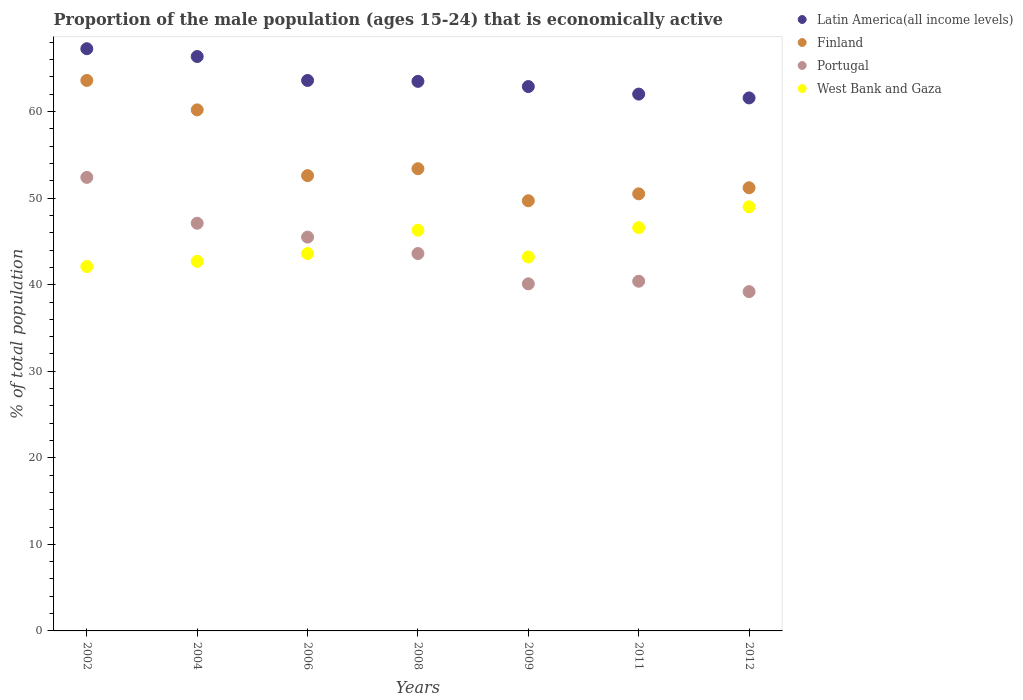What is the proportion of the male population that is economically active in Portugal in 2009?
Ensure brevity in your answer.  40.1. Across all years, what is the minimum proportion of the male population that is economically active in Portugal?
Provide a succinct answer. 39.2. In which year was the proportion of the male population that is economically active in Portugal maximum?
Offer a very short reply. 2002. In which year was the proportion of the male population that is economically active in Portugal minimum?
Keep it short and to the point. 2012. What is the total proportion of the male population that is economically active in West Bank and Gaza in the graph?
Offer a very short reply. 313.5. What is the difference between the proportion of the male population that is economically active in Finland in 2006 and that in 2009?
Your answer should be very brief. 2.9. What is the difference between the proportion of the male population that is economically active in West Bank and Gaza in 2011 and the proportion of the male population that is economically active in Latin America(all income levels) in 2002?
Your response must be concise. -20.66. What is the average proportion of the male population that is economically active in Portugal per year?
Provide a succinct answer. 44.04. In the year 2009, what is the difference between the proportion of the male population that is economically active in Latin America(all income levels) and proportion of the male population that is economically active in West Bank and Gaza?
Give a very brief answer. 19.69. What is the ratio of the proportion of the male population that is economically active in West Bank and Gaza in 2002 to that in 2011?
Keep it short and to the point. 0.9. Is the proportion of the male population that is economically active in West Bank and Gaza in 2002 less than that in 2006?
Provide a short and direct response. Yes. Is the difference between the proportion of the male population that is economically active in Latin America(all income levels) in 2008 and 2011 greater than the difference between the proportion of the male population that is economically active in West Bank and Gaza in 2008 and 2011?
Your response must be concise. Yes. What is the difference between the highest and the second highest proportion of the male population that is economically active in West Bank and Gaza?
Your answer should be compact. 2.4. What is the difference between the highest and the lowest proportion of the male population that is economically active in Finland?
Give a very brief answer. 13.9. In how many years, is the proportion of the male population that is economically active in West Bank and Gaza greater than the average proportion of the male population that is economically active in West Bank and Gaza taken over all years?
Your answer should be very brief. 3. Is the sum of the proportion of the male population that is economically active in Portugal in 2008 and 2009 greater than the maximum proportion of the male population that is economically active in Finland across all years?
Provide a succinct answer. Yes. Is it the case that in every year, the sum of the proportion of the male population that is economically active in Portugal and proportion of the male population that is economically active in West Bank and Gaza  is greater than the sum of proportion of the male population that is economically active in Latin America(all income levels) and proportion of the male population that is economically active in Finland?
Offer a terse response. No. Is the proportion of the male population that is economically active in Latin America(all income levels) strictly less than the proportion of the male population that is economically active in Finland over the years?
Make the answer very short. No. How many years are there in the graph?
Keep it short and to the point. 7. Are the values on the major ticks of Y-axis written in scientific E-notation?
Offer a terse response. No. Does the graph contain any zero values?
Offer a terse response. No. What is the title of the graph?
Your answer should be very brief. Proportion of the male population (ages 15-24) that is economically active. What is the label or title of the X-axis?
Your response must be concise. Years. What is the label or title of the Y-axis?
Give a very brief answer. % of total population. What is the % of total population of Latin America(all income levels) in 2002?
Make the answer very short. 67.26. What is the % of total population in Finland in 2002?
Ensure brevity in your answer.  63.6. What is the % of total population in Portugal in 2002?
Your answer should be compact. 52.4. What is the % of total population in West Bank and Gaza in 2002?
Provide a short and direct response. 42.1. What is the % of total population of Latin America(all income levels) in 2004?
Offer a terse response. 66.36. What is the % of total population in Finland in 2004?
Provide a succinct answer. 60.2. What is the % of total population in Portugal in 2004?
Give a very brief answer. 47.1. What is the % of total population in West Bank and Gaza in 2004?
Your answer should be very brief. 42.7. What is the % of total population of Latin America(all income levels) in 2006?
Give a very brief answer. 63.6. What is the % of total population of Finland in 2006?
Provide a short and direct response. 52.6. What is the % of total population in Portugal in 2006?
Provide a succinct answer. 45.5. What is the % of total population in West Bank and Gaza in 2006?
Your response must be concise. 43.6. What is the % of total population of Latin America(all income levels) in 2008?
Provide a succinct answer. 63.49. What is the % of total population in Finland in 2008?
Provide a short and direct response. 53.4. What is the % of total population in Portugal in 2008?
Offer a terse response. 43.6. What is the % of total population in West Bank and Gaza in 2008?
Your response must be concise. 46.3. What is the % of total population in Latin America(all income levels) in 2009?
Ensure brevity in your answer.  62.89. What is the % of total population in Finland in 2009?
Your answer should be compact. 49.7. What is the % of total population in Portugal in 2009?
Ensure brevity in your answer.  40.1. What is the % of total population of West Bank and Gaza in 2009?
Offer a very short reply. 43.2. What is the % of total population of Latin America(all income levels) in 2011?
Provide a succinct answer. 62.02. What is the % of total population in Finland in 2011?
Make the answer very short. 50.5. What is the % of total population in Portugal in 2011?
Keep it short and to the point. 40.4. What is the % of total population of West Bank and Gaza in 2011?
Offer a very short reply. 46.6. What is the % of total population in Latin America(all income levels) in 2012?
Your response must be concise. 61.58. What is the % of total population in Finland in 2012?
Keep it short and to the point. 51.2. What is the % of total population of Portugal in 2012?
Offer a terse response. 39.2. Across all years, what is the maximum % of total population of Latin America(all income levels)?
Your answer should be compact. 67.26. Across all years, what is the maximum % of total population of Finland?
Offer a very short reply. 63.6. Across all years, what is the maximum % of total population in Portugal?
Keep it short and to the point. 52.4. Across all years, what is the maximum % of total population of West Bank and Gaza?
Give a very brief answer. 49. Across all years, what is the minimum % of total population of Latin America(all income levels)?
Make the answer very short. 61.58. Across all years, what is the minimum % of total population in Finland?
Your answer should be very brief. 49.7. Across all years, what is the minimum % of total population in Portugal?
Your answer should be very brief. 39.2. Across all years, what is the minimum % of total population in West Bank and Gaza?
Provide a short and direct response. 42.1. What is the total % of total population in Latin America(all income levels) in the graph?
Offer a terse response. 447.21. What is the total % of total population in Finland in the graph?
Your response must be concise. 381.2. What is the total % of total population in Portugal in the graph?
Ensure brevity in your answer.  308.3. What is the total % of total population of West Bank and Gaza in the graph?
Give a very brief answer. 313.5. What is the difference between the % of total population of Latin America(all income levels) in 2002 and that in 2004?
Give a very brief answer. 0.9. What is the difference between the % of total population in Finland in 2002 and that in 2004?
Give a very brief answer. 3.4. What is the difference between the % of total population of Portugal in 2002 and that in 2004?
Your response must be concise. 5.3. What is the difference between the % of total population of West Bank and Gaza in 2002 and that in 2004?
Offer a terse response. -0.6. What is the difference between the % of total population in Latin America(all income levels) in 2002 and that in 2006?
Your response must be concise. 3.67. What is the difference between the % of total population of Finland in 2002 and that in 2006?
Offer a very short reply. 11. What is the difference between the % of total population of West Bank and Gaza in 2002 and that in 2006?
Offer a very short reply. -1.5. What is the difference between the % of total population of Latin America(all income levels) in 2002 and that in 2008?
Offer a very short reply. 3.77. What is the difference between the % of total population of Finland in 2002 and that in 2008?
Give a very brief answer. 10.2. What is the difference between the % of total population in Portugal in 2002 and that in 2008?
Offer a very short reply. 8.8. What is the difference between the % of total population of Latin America(all income levels) in 2002 and that in 2009?
Keep it short and to the point. 4.37. What is the difference between the % of total population of Finland in 2002 and that in 2009?
Make the answer very short. 13.9. What is the difference between the % of total population of West Bank and Gaza in 2002 and that in 2009?
Offer a very short reply. -1.1. What is the difference between the % of total population in Latin America(all income levels) in 2002 and that in 2011?
Your answer should be very brief. 5.24. What is the difference between the % of total population in Finland in 2002 and that in 2011?
Your answer should be compact. 13.1. What is the difference between the % of total population in West Bank and Gaza in 2002 and that in 2011?
Offer a terse response. -4.5. What is the difference between the % of total population of Latin America(all income levels) in 2002 and that in 2012?
Ensure brevity in your answer.  5.69. What is the difference between the % of total population in West Bank and Gaza in 2002 and that in 2012?
Provide a short and direct response. -6.9. What is the difference between the % of total population of Latin America(all income levels) in 2004 and that in 2006?
Provide a short and direct response. 2.77. What is the difference between the % of total population in Portugal in 2004 and that in 2006?
Give a very brief answer. 1.6. What is the difference between the % of total population of West Bank and Gaza in 2004 and that in 2006?
Keep it short and to the point. -0.9. What is the difference between the % of total population in Latin America(all income levels) in 2004 and that in 2008?
Give a very brief answer. 2.87. What is the difference between the % of total population of Finland in 2004 and that in 2008?
Ensure brevity in your answer.  6.8. What is the difference between the % of total population of Latin America(all income levels) in 2004 and that in 2009?
Offer a terse response. 3.47. What is the difference between the % of total population of Portugal in 2004 and that in 2009?
Offer a terse response. 7. What is the difference between the % of total population in Latin America(all income levels) in 2004 and that in 2011?
Your answer should be compact. 4.34. What is the difference between the % of total population of Finland in 2004 and that in 2011?
Provide a succinct answer. 9.7. What is the difference between the % of total population in Portugal in 2004 and that in 2011?
Provide a succinct answer. 6.7. What is the difference between the % of total population of Latin America(all income levels) in 2004 and that in 2012?
Your answer should be very brief. 4.78. What is the difference between the % of total population in West Bank and Gaza in 2004 and that in 2012?
Give a very brief answer. -6.3. What is the difference between the % of total population in Latin America(all income levels) in 2006 and that in 2008?
Provide a short and direct response. 0.1. What is the difference between the % of total population in Finland in 2006 and that in 2008?
Provide a short and direct response. -0.8. What is the difference between the % of total population in Portugal in 2006 and that in 2008?
Offer a very short reply. 1.9. What is the difference between the % of total population of Latin America(all income levels) in 2006 and that in 2009?
Give a very brief answer. 0.7. What is the difference between the % of total population in Latin America(all income levels) in 2006 and that in 2011?
Offer a very short reply. 1.58. What is the difference between the % of total population in Latin America(all income levels) in 2006 and that in 2012?
Make the answer very short. 2.02. What is the difference between the % of total population in Finland in 2006 and that in 2012?
Your response must be concise. 1.4. What is the difference between the % of total population in Portugal in 2006 and that in 2012?
Make the answer very short. 6.3. What is the difference between the % of total population in West Bank and Gaza in 2006 and that in 2012?
Keep it short and to the point. -5.4. What is the difference between the % of total population in Latin America(all income levels) in 2008 and that in 2009?
Ensure brevity in your answer.  0.6. What is the difference between the % of total population in Portugal in 2008 and that in 2009?
Ensure brevity in your answer.  3.5. What is the difference between the % of total population in West Bank and Gaza in 2008 and that in 2009?
Ensure brevity in your answer.  3.1. What is the difference between the % of total population of Latin America(all income levels) in 2008 and that in 2011?
Give a very brief answer. 1.47. What is the difference between the % of total population of Finland in 2008 and that in 2011?
Provide a short and direct response. 2.9. What is the difference between the % of total population in Portugal in 2008 and that in 2011?
Your answer should be very brief. 3.2. What is the difference between the % of total population of Latin America(all income levels) in 2008 and that in 2012?
Offer a very short reply. 1.91. What is the difference between the % of total population in Portugal in 2008 and that in 2012?
Give a very brief answer. 4.4. What is the difference between the % of total population of Latin America(all income levels) in 2009 and that in 2011?
Give a very brief answer. 0.87. What is the difference between the % of total population of Portugal in 2009 and that in 2011?
Your answer should be compact. -0.3. What is the difference between the % of total population in Latin America(all income levels) in 2009 and that in 2012?
Provide a short and direct response. 1.31. What is the difference between the % of total population in Finland in 2009 and that in 2012?
Provide a short and direct response. -1.5. What is the difference between the % of total population in Portugal in 2009 and that in 2012?
Your answer should be compact. 0.9. What is the difference between the % of total population of Latin America(all income levels) in 2011 and that in 2012?
Ensure brevity in your answer.  0.44. What is the difference between the % of total population in Finland in 2011 and that in 2012?
Give a very brief answer. -0.7. What is the difference between the % of total population of Portugal in 2011 and that in 2012?
Provide a succinct answer. 1.2. What is the difference between the % of total population in Latin America(all income levels) in 2002 and the % of total population in Finland in 2004?
Your answer should be compact. 7.06. What is the difference between the % of total population of Latin America(all income levels) in 2002 and the % of total population of Portugal in 2004?
Give a very brief answer. 20.16. What is the difference between the % of total population in Latin America(all income levels) in 2002 and the % of total population in West Bank and Gaza in 2004?
Provide a succinct answer. 24.56. What is the difference between the % of total population of Finland in 2002 and the % of total population of Portugal in 2004?
Offer a terse response. 16.5. What is the difference between the % of total population of Finland in 2002 and the % of total population of West Bank and Gaza in 2004?
Give a very brief answer. 20.9. What is the difference between the % of total population in Portugal in 2002 and the % of total population in West Bank and Gaza in 2004?
Provide a short and direct response. 9.7. What is the difference between the % of total population of Latin America(all income levels) in 2002 and the % of total population of Finland in 2006?
Offer a very short reply. 14.66. What is the difference between the % of total population of Latin America(all income levels) in 2002 and the % of total population of Portugal in 2006?
Your answer should be very brief. 21.76. What is the difference between the % of total population of Latin America(all income levels) in 2002 and the % of total population of West Bank and Gaza in 2006?
Keep it short and to the point. 23.66. What is the difference between the % of total population in Finland in 2002 and the % of total population in West Bank and Gaza in 2006?
Give a very brief answer. 20. What is the difference between the % of total population of Latin America(all income levels) in 2002 and the % of total population of Finland in 2008?
Your answer should be very brief. 13.86. What is the difference between the % of total population in Latin America(all income levels) in 2002 and the % of total population in Portugal in 2008?
Ensure brevity in your answer.  23.66. What is the difference between the % of total population in Latin America(all income levels) in 2002 and the % of total population in West Bank and Gaza in 2008?
Provide a short and direct response. 20.96. What is the difference between the % of total population of Finland in 2002 and the % of total population of Portugal in 2008?
Provide a short and direct response. 20. What is the difference between the % of total population in Latin America(all income levels) in 2002 and the % of total population in Finland in 2009?
Your answer should be compact. 17.56. What is the difference between the % of total population of Latin America(all income levels) in 2002 and the % of total population of Portugal in 2009?
Your response must be concise. 27.16. What is the difference between the % of total population in Latin America(all income levels) in 2002 and the % of total population in West Bank and Gaza in 2009?
Keep it short and to the point. 24.06. What is the difference between the % of total population in Finland in 2002 and the % of total population in West Bank and Gaza in 2009?
Give a very brief answer. 20.4. What is the difference between the % of total population in Portugal in 2002 and the % of total population in West Bank and Gaza in 2009?
Keep it short and to the point. 9.2. What is the difference between the % of total population of Latin America(all income levels) in 2002 and the % of total population of Finland in 2011?
Keep it short and to the point. 16.76. What is the difference between the % of total population of Latin America(all income levels) in 2002 and the % of total population of Portugal in 2011?
Your response must be concise. 26.86. What is the difference between the % of total population of Latin America(all income levels) in 2002 and the % of total population of West Bank and Gaza in 2011?
Your answer should be very brief. 20.66. What is the difference between the % of total population of Finland in 2002 and the % of total population of Portugal in 2011?
Give a very brief answer. 23.2. What is the difference between the % of total population in Finland in 2002 and the % of total population in West Bank and Gaza in 2011?
Keep it short and to the point. 17. What is the difference between the % of total population of Portugal in 2002 and the % of total population of West Bank and Gaza in 2011?
Offer a terse response. 5.8. What is the difference between the % of total population of Latin America(all income levels) in 2002 and the % of total population of Finland in 2012?
Make the answer very short. 16.06. What is the difference between the % of total population in Latin America(all income levels) in 2002 and the % of total population in Portugal in 2012?
Give a very brief answer. 28.06. What is the difference between the % of total population of Latin America(all income levels) in 2002 and the % of total population of West Bank and Gaza in 2012?
Your answer should be compact. 18.26. What is the difference between the % of total population in Finland in 2002 and the % of total population in Portugal in 2012?
Give a very brief answer. 24.4. What is the difference between the % of total population in Finland in 2002 and the % of total population in West Bank and Gaza in 2012?
Keep it short and to the point. 14.6. What is the difference between the % of total population in Latin America(all income levels) in 2004 and the % of total population in Finland in 2006?
Offer a very short reply. 13.76. What is the difference between the % of total population in Latin America(all income levels) in 2004 and the % of total population in Portugal in 2006?
Offer a very short reply. 20.86. What is the difference between the % of total population of Latin America(all income levels) in 2004 and the % of total population of West Bank and Gaza in 2006?
Provide a succinct answer. 22.76. What is the difference between the % of total population in Finland in 2004 and the % of total population in Portugal in 2006?
Keep it short and to the point. 14.7. What is the difference between the % of total population of Latin America(all income levels) in 2004 and the % of total population of Finland in 2008?
Your answer should be very brief. 12.96. What is the difference between the % of total population of Latin America(all income levels) in 2004 and the % of total population of Portugal in 2008?
Your answer should be very brief. 22.76. What is the difference between the % of total population in Latin America(all income levels) in 2004 and the % of total population in West Bank and Gaza in 2008?
Provide a succinct answer. 20.06. What is the difference between the % of total population of Finland in 2004 and the % of total population of West Bank and Gaza in 2008?
Your answer should be compact. 13.9. What is the difference between the % of total population in Latin America(all income levels) in 2004 and the % of total population in Finland in 2009?
Make the answer very short. 16.66. What is the difference between the % of total population of Latin America(all income levels) in 2004 and the % of total population of Portugal in 2009?
Provide a succinct answer. 26.26. What is the difference between the % of total population in Latin America(all income levels) in 2004 and the % of total population in West Bank and Gaza in 2009?
Provide a succinct answer. 23.16. What is the difference between the % of total population of Finland in 2004 and the % of total population of Portugal in 2009?
Make the answer very short. 20.1. What is the difference between the % of total population of Finland in 2004 and the % of total population of West Bank and Gaza in 2009?
Make the answer very short. 17. What is the difference between the % of total population in Portugal in 2004 and the % of total population in West Bank and Gaza in 2009?
Provide a succinct answer. 3.9. What is the difference between the % of total population of Latin America(all income levels) in 2004 and the % of total population of Finland in 2011?
Keep it short and to the point. 15.86. What is the difference between the % of total population of Latin America(all income levels) in 2004 and the % of total population of Portugal in 2011?
Provide a short and direct response. 25.96. What is the difference between the % of total population of Latin America(all income levels) in 2004 and the % of total population of West Bank and Gaza in 2011?
Keep it short and to the point. 19.76. What is the difference between the % of total population of Finland in 2004 and the % of total population of Portugal in 2011?
Provide a short and direct response. 19.8. What is the difference between the % of total population in Finland in 2004 and the % of total population in West Bank and Gaza in 2011?
Your answer should be very brief. 13.6. What is the difference between the % of total population in Portugal in 2004 and the % of total population in West Bank and Gaza in 2011?
Offer a very short reply. 0.5. What is the difference between the % of total population in Latin America(all income levels) in 2004 and the % of total population in Finland in 2012?
Keep it short and to the point. 15.16. What is the difference between the % of total population in Latin America(all income levels) in 2004 and the % of total population in Portugal in 2012?
Make the answer very short. 27.16. What is the difference between the % of total population of Latin America(all income levels) in 2004 and the % of total population of West Bank and Gaza in 2012?
Make the answer very short. 17.36. What is the difference between the % of total population of Finland in 2004 and the % of total population of Portugal in 2012?
Offer a very short reply. 21. What is the difference between the % of total population in Finland in 2004 and the % of total population in West Bank and Gaza in 2012?
Ensure brevity in your answer.  11.2. What is the difference between the % of total population of Latin America(all income levels) in 2006 and the % of total population of Finland in 2008?
Ensure brevity in your answer.  10.2. What is the difference between the % of total population of Latin America(all income levels) in 2006 and the % of total population of Portugal in 2008?
Provide a succinct answer. 20. What is the difference between the % of total population of Latin America(all income levels) in 2006 and the % of total population of West Bank and Gaza in 2008?
Give a very brief answer. 17.3. What is the difference between the % of total population of Finland in 2006 and the % of total population of West Bank and Gaza in 2008?
Give a very brief answer. 6.3. What is the difference between the % of total population of Latin America(all income levels) in 2006 and the % of total population of Finland in 2009?
Provide a succinct answer. 13.9. What is the difference between the % of total population in Latin America(all income levels) in 2006 and the % of total population in Portugal in 2009?
Make the answer very short. 23.5. What is the difference between the % of total population of Latin America(all income levels) in 2006 and the % of total population of West Bank and Gaza in 2009?
Offer a very short reply. 20.4. What is the difference between the % of total population in Finland in 2006 and the % of total population in Portugal in 2009?
Offer a very short reply. 12.5. What is the difference between the % of total population in Portugal in 2006 and the % of total population in West Bank and Gaza in 2009?
Your answer should be compact. 2.3. What is the difference between the % of total population in Latin America(all income levels) in 2006 and the % of total population in Finland in 2011?
Give a very brief answer. 13.1. What is the difference between the % of total population in Latin America(all income levels) in 2006 and the % of total population in Portugal in 2011?
Offer a terse response. 23.2. What is the difference between the % of total population of Latin America(all income levels) in 2006 and the % of total population of West Bank and Gaza in 2011?
Keep it short and to the point. 17. What is the difference between the % of total population in Finland in 2006 and the % of total population in West Bank and Gaza in 2011?
Ensure brevity in your answer.  6. What is the difference between the % of total population of Portugal in 2006 and the % of total population of West Bank and Gaza in 2011?
Your answer should be very brief. -1.1. What is the difference between the % of total population of Latin America(all income levels) in 2006 and the % of total population of Finland in 2012?
Offer a terse response. 12.4. What is the difference between the % of total population of Latin America(all income levels) in 2006 and the % of total population of Portugal in 2012?
Provide a succinct answer. 24.4. What is the difference between the % of total population in Latin America(all income levels) in 2006 and the % of total population in West Bank and Gaza in 2012?
Ensure brevity in your answer.  14.6. What is the difference between the % of total population in Finland in 2006 and the % of total population in Portugal in 2012?
Give a very brief answer. 13.4. What is the difference between the % of total population of Finland in 2006 and the % of total population of West Bank and Gaza in 2012?
Keep it short and to the point. 3.6. What is the difference between the % of total population of Latin America(all income levels) in 2008 and the % of total population of Finland in 2009?
Make the answer very short. 13.79. What is the difference between the % of total population in Latin America(all income levels) in 2008 and the % of total population in Portugal in 2009?
Make the answer very short. 23.39. What is the difference between the % of total population in Latin America(all income levels) in 2008 and the % of total population in West Bank and Gaza in 2009?
Keep it short and to the point. 20.29. What is the difference between the % of total population in Finland in 2008 and the % of total population in Portugal in 2009?
Make the answer very short. 13.3. What is the difference between the % of total population in Portugal in 2008 and the % of total population in West Bank and Gaza in 2009?
Give a very brief answer. 0.4. What is the difference between the % of total population of Latin America(all income levels) in 2008 and the % of total population of Finland in 2011?
Offer a very short reply. 12.99. What is the difference between the % of total population in Latin America(all income levels) in 2008 and the % of total population in Portugal in 2011?
Ensure brevity in your answer.  23.09. What is the difference between the % of total population in Latin America(all income levels) in 2008 and the % of total population in West Bank and Gaza in 2011?
Your answer should be very brief. 16.89. What is the difference between the % of total population of Finland in 2008 and the % of total population of Portugal in 2011?
Give a very brief answer. 13. What is the difference between the % of total population in Portugal in 2008 and the % of total population in West Bank and Gaza in 2011?
Your answer should be compact. -3. What is the difference between the % of total population in Latin America(all income levels) in 2008 and the % of total population in Finland in 2012?
Offer a very short reply. 12.29. What is the difference between the % of total population of Latin America(all income levels) in 2008 and the % of total population of Portugal in 2012?
Your answer should be very brief. 24.29. What is the difference between the % of total population in Latin America(all income levels) in 2008 and the % of total population in West Bank and Gaza in 2012?
Give a very brief answer. 14.49. What is the difference between the % of total population of Finland in 2008 and the % of total population of West Bank and Gaza in 2012?
Your response must be concise. 4.4. What is the difference between the % of total population in Portugal in 2008 and the % of total population in West Bank and Gaza in 2012?
Your answer should be very brief. -5.4. What is the difference between the % of total population of Latin America(all income levels) in 2009 and the % of total population of Finland in 2011?
Your response must be concise. 12.39. What is the difference between the % of total population in Latin America(all income levels) in 2009 and the % of total population in Portugal in 2011?
Keep it short and to the point. 22.49. What is the difference between the % of total population of Latin America(all income levels) in 2009 and the % of total population of West Bank and Gaza in 2011?
Offer a very short reply. 16.29. What is the difference between the % of total population in Finland in 2009 and the % of total population in West Bank and Gaza in 2011?
Give a very brief answer. 3.1. What is the difference between the % of total population of Latin America(all income levels) in 2009 and the % of total population of Finland in 2012?
Keep it short and to the point. 11.69. What is the difference between the % of total population of Latin America(all income levels) in 2009 and the % of total population of Portugal in 2012?
Your answer should be compact. 23.69. What is the difference between the % of total population in Latin America(all income levels) in 2009 and the % of total population in West Bank and Gaza in 2012?
Provide a succinct answer. 13.89. What is the difference between the % of total population in Finland in 2009 and the % of total population in Portugal in 2012?
Keep it short and to the point. 10.5. What is the difference between the % of total population of Finland in 2009 and the % of total population of West Bank and Gaza in 2012?
Make the answer very short. 0.7. What is the difference between the % of total population of Portugal in 2009 and the % of total population of West Bank and Gaza in 2012?
Offer a very short reply. -8.9. What is the difference between the % of total population in Latin America(all income levels) in 2011 and the % of total population in Finland in 2012?
Your answer should be very brief. 10.82. What is the difference between the % of total population in Latin America(all income levels) in 2011 and the % of total population in Portugal in 2012?
Ensure brevity in your answer.  22.82. What is the difference between the % of total population of Latin America(all income levels) in 2011 and the % of total population of West Bank and Gaza in 2012?
Ensure brevity in your answer.  13.02. What is the difference between the % of total population of Finland in 2011 and the % of total population of West Bank and Gaza in 2012?
Offer a very short reply. 1.5. What is the difference between the % of total population in Portugal in 2011 and the % of total population in West Bank and Gaza in 2012?
Make the answer very short. -8.6. What is the average % of total population of Latin America(all income levels) per year?
Provide a short and direct response. 63.89. What is the average % of total population of Finland per year?
Offer a very short reply. 54.46. What is the average % of total population of Portugal per year?
Provide a succinct answer. 44.04. What is the average % of total population of West Bank and Gaza per year?
Provide a short and direct response. 44.79. In the year 2002, what is the difference between the % of total population of Latin America(all income levels) and % of total population of Finland?
Offer a very short reply. 3.66. In the year 2002, what is the difference between the % of total population in Latin America(all income levels) and % of total population in Portugal?
Offer a terse response. 14.86. In the year 2002, what is the difference between the % of total population of Latin America(all income levels) and % of total population of West Bank and Gaza?
Give a very brief answer. 25.16. In the year 2004, what is the difference between the % of total population in Latin America(all income levels) and % of total population in Finland?
Offer a very short reply. 6.16. In the year 2004, what is the difference between the % of total population in Latin America(all income levels) and % of total population in Portugal?
Keep it short and to the point. 19.26. In the year 2004, what is the difference between the % of total population in Latin America(all income levels) and % of total population in West Bank and Gaza?
Your answer should be compact. 23.66. In the year 2004, what is the difference between the % of total population of Finland and % of total population of Portugal?
Make the answer very short. 13.1. In the year 2006, what is the difference between the % of total population of Latin America(all income levels) and % of total population of Finland?
Your response must be concise. 11. In the year 2006, what is the difference between the % of total population in Latin America(all income levels) and % of total population in Portugal?
Provide a short and direct response. 18.1. In the year 2006, what is the difference between the % of total population of Latin America(all income levels) and % of total population of West Bank and Gaza?
Offer a very short reply. 20. In the year 2006, what is the difference between the % of total population of Finland and % of total population of Portugal?
Your response must be concise. 7.1. In the year 2006, what is the difference between the % of total population in Finland and % of total population in West Bank and Gaza?
Give a very brief answer. 9. In the year 2006, what is the difference between the % of total population in Portugal and % of total population in West Bank and Gaza?
Ensure brevity in your answer.  1.9. In the year 2008, what is the difference between the % of total population of Latin America(all income levels) and % of total population of Finland?
Ensure brevity in your answer.  10.09. In the year 2008, what is the difference between the % of total population of Latin America(all income levels) and % of total population of Portugal?
Ensure brevity in your answer.  19.89. In the year 2008, what is the difference between the % of total population of Latin America(all income levels) and % of total population of West Bank and Gaza?
Give a very brief answer. 17.19. In the year 2009, what is the difference between the % of total population in Latin America(all income levels) and % of total population in Finland?
Your response must be concise. 13.19. In the year 2009, what is the difference between the % of total population in Latin America(all income levels) and % of total population in Portugal?
Your answer should be very brief. 22.79. In the year 2009, what is the difference between the % of total population of Latin America(all income levels) and % of total population of West Bank and Gaza?
Your response must be concise. 19.69. In the year 2009, what is the difference between the % of total population in Finland and % of total population in Portugal?
Your answer should be very brief. 9.6. In the year 2009, what is the difference between the % of total population of Finland and % of total population of West Bank and Gaza?
Ensure brevity in your answer.  6.5. In the year 2011, what is the difference between the % of total population of Latin America(all income levels) and % of total population of Finland?
Ensure brevity in your answer.  11.52. In the year 2011, what is the difference between the % of total population of Latin America(all income levels) and % of total population of Portugal?
Ensure brevity in your answer.  21.62. In the year 2011, what is the difference between the % of total population in Latin America(all income levels) and % of total population in West Bank and Gaza?
Provide a succinct answer. 15.42. In the year 2011, what is the difference between the % of total population of Finland and % of total population of Portugal?
Provide a succinct answer. 10.1. In the year 2011, what is the difference between the % of total population of Finland and % of total population of West Bank and Gaza?
Offer a very short reply. 3.9. In the year 2011, what is the difference between the % of total population in Portugal and % of total population in West Bank and Gaza?
Give a very brief answer. -6.2. In the year 2012, what is the difference between the % of total population in Latin America(all income levels) and % of total population in Finland?
Ensure brevity in your answer.  10.38. In the year 2012, what is the difference between the % of total population in Latin America(all income levels) and % of total population in Portugal?
Offer a very short reply. 22.38. In the year 2012, what is the difference between the % of total population of Latin America(all income levels) and % of total population of West Bank and Gaza?
Provide a short and direct response. 12.58. In the year 2012, what is the difference between the % of total population of Portugal and % of total population of West Bank and Gaza?
Offer a terse response. -9.8. What is the ratio of the % of total population in Latin America(all income levels) in 2002 to that in 2004?
Give a very brief answer. 1.01. What is the ratio of the % of total population of Finland in 2002 to that in 2004?
Give a very brief answer. 1.06. What is the ratio of the % of total population in Portugal in 2002 to that in 2004?
Your response must be concise. 1.11. What is the ratio of the % of total population in West Bank and Gaza in 2002 to that in 2004?
Your answer should be compact. 0.99. What is the ratio of the % of total population of Latin America(all income levels) in 2002 to that in 2006?
Provide a short and direct response. 1.06. What is the ratio of the % of total population in Finland in 2002 to that in 2006?
Provide a succinct answer. 1.21. What is the ratio of the % of total population of Portugal in 2002 to that in 2006?
Offer a terse response. 1.15. What is the ratio of the % of total population in West Bank and Gaza in 2002 to that in 2006?
Give a very brief answer. 0.97. What is the ratio of the % of total population of Latin America(all income levels) in 2002 to that in 2008?
Ensure brevity in your answer.  1.06. What is the ratio of the % of total population in Finland in 2002 to that in 2008?
Give a very brief answer. 1.19. What is the ratio of the % of total population in Portugal in 2002 to that in 2008?
Your answer should be very brief. 1.2. What is the ratio of the % of total population in West Bank and Gaza in 2002 to that in 2008?
Provide a short and direct response. 0.91. What is the ratio of the % of total population in Latin America(all income levels) in 2002 to that in 2009?
Provide a succinct answer. 1.07. What is the ratio of the % of total population of Finland in 2002 to that in 2009?
Your answer should be compact. 1.28. What is the ratio of the % of total population in Portugal in 2002 to that in 2009?
Ensure brevity in your answer.  1.31. What is the ratio of the % of total population in West Bank and Gaza in 2002 to that in 2009?
Give a very brief answer. 0.97. What is the ratio of the % of total population in Latin America(all income levels) in 2002 to that in 2011?
Make the answer very short. 1.08. What is the ratio of the % of total population in Finland in 2002 to that in 2011?
Your answer should be compact. 1.26. What is the ratio of the % of total population in Portugal in 2002 to that in 2011?
Keep it short and to the point. 1.3. What is the ratio of the % of total population of West Bank and Gaza in 2002 to that in 2011?
Give a very brief answer. 0.9. What is the ratio of the % of total population of Latin America(all income levels) in 2002 to that in 2012?
Offer a terse response. 1.09. What is the ratio of the % of total population in Finland in 2002 to that in 2012?
Provide a succinct answer. 1.24. What is the ratio of the % of total population of Portugal in 2002 to that in 2012?
Offer a very short reply. 1.34. What is the ratio of the % of total population in West Bank and Gaza in 2002 to that in 2012?
Your answer should be compact. 0.86. What is the ratio of the % of total population of Latin America(all income levels) in 2004 to that in 2006?
Give a very brief answer. 1.04. What is the ratio of the % of total population in Finland in 2004 to that in 2006?
Give a very brief answer. 1.14. What is the ratio of the % of total population in Portugal in 2004 to that in 2006?
Your response must be concise. 1.04. What is the ratio of the % of total population in West Bank and Gaza in 2004 to that in 2006?
Make the answer very short. 0.98. What is the ratio of the % of total population of Latin America(all income levels) in 2004 to that in 2008?
Provide a succinct answer. 1.05. What is the ratio of the % of total population in Finland in 2004 to that in 2008?
Give a very brief answer. 1.13. What is the ratio of the % of total population of Portugal in 2004 to that in 2008?
Keep it short and to the point. 1.08. What is the ratio of the % of total population in West Bank and Gaza in 2004 to that in 2008?
Your response must be concise. 0.92. What is the ratio of the % of total population of Latin America(all income levels) in 2004 to that in 2009?
Offer a terse response. 1.06. What is the ratio of the % of total population of Finland in 2004 to that in 2009?
Make the answer very short. 1.21. What is the ratio of the % of total population of Portugal in 2004 to that in 2009?
Provide a succinct answer. 1.17. What is the ratio of the % of total population of West Bank and Gaza in 2004 to that in 2009?
Ensure brevity in your answer.  0.99. What is the ratio of the % of total population of Latin America(all income levels) in 2004 to that in 2011?
Your answer should be very brief. 1.07. What is the ratio of the % of total population of Finland in 2004 to that in 2011?
Your answer should be very brief. 1.19. What is the ratio of the % of total population in Portugal in 2004 to that in 2011?
Offer a terse response. 1.17. What is the ratio of the % of total population in West Bank and Gaza in 2004 to that in 2011?
Your answer should be very brief. 0.92. What is the ratio of the % of total population of Latin America(all income levels) in 2004 to that in 2012?
Your answer should be very brief. 1.08. What is the ratio of the % of total population in Finland in 2004 to that in 2012?
Your answer should be compact. 1.18. What is the ratio of the % of total population of Portugal in 2004 to that in 2012?
Provide a succinct answer. 1.2. What is the ratio of the % of total population in West Bank and Gaza in 2004 to that in 2012?
Your answer should be very brief. 0.87. What is the ratio of the % of total population in Latin America(all income levels) in 2006 to that in 2008?
Offer a terse response. 1. What is the ratio of the % of total population of Portugal in 2006 to that in 2008?
Offer a terse response. 1.04. What is the ratio of the % of total population of West Bank and Gaza in 2006 to that in 2008?
Offer a terse response. 0.94. What is the ratio of the % of total population of Latin America(all income levels) in 2006 to that in 2009?
Ensure brevity in your answer.  1.01. What is the ratio of the % of total population of Finland in 2006 to that in 2009?
Provide a succinct answer. 1.06. What is the ratio of the % of total population of Portugal in 2006 to that in 2009?
Your answer should be compact. 1.13. What is the ratio of the % of total population in West Bank and Gaza in 2006 to that in 2009?
Make the answer very short. 1.01. What is the ratio of the % of total population in Latin America(all income levels) in 2006 to that in 2011?
Your answer should be compact. 1.03. What is the ratio of the % of total population of Finland in 2006 to that in 2011?
Your response must be concise. 1.04. What is the ratio of the % of total population of Portugal in 2006 to that in 2011?
Your response must be concise. 1.13. What is the ratio of the % of total population in West Bank and Gaza in 2006 to that in 2011?
Offer a very short reply. 0.94. What is the ratio of the % of total population of Latin America(all income levels) in 2006 to that in 2012?
Provide a short and direct response. 1.03. What is the ratio of the % of total population in Finland in 2006 to that in 2012?
Your answer should be very brief. 1.03. What is the ratio of the % of total population of Portugal in 2006 to that in 2012?
Keep it short and to the point. 1.16. What is the ratio of the % of total population of West Bank and Gaza in 2006 to that in 2012?
Keep it short and to the point. 0.89. What is the ratio of the % of total population of Latin America(all income levels) in 2008 to that in 2009?
Make the answer very short. 1.01. What is the ratio of the % of total population of Finland in 2008 to that in 2009?
Ensure brevity in your answer.  1.07. What is the ratio of the % of total population of Portugal in 2008 to that in 2009?
Provide a succinct answer. 1.09. What is the ratio of the % of total population in West Bank and Gaza in 2008 to that in 2009?
Provide a short and direct response. 1.07. What is the ratio of the % of total population of Latin America(all income levels) in 2008 to that in 2011?
Provide a succinct answer. 1.02. What is the ratio of the % of total population of Finland in 2008 to that in 2011?
Your response must be concise. 1.06. What is the ratio of the % of total population in Portugal in 2008 to that in 2011?
Ensure brevity in your answer.  1.08. What is the ratio of the % of total population in West Bank and Gaza in 2008 to that in 2011?
Your answer should be very brief. 0.99. What is the ratio of the % of total population of Latin America(all income levels) in 2008 to that in 2012?
Your response must be concise. 1.03. What is the ratio of the % of total population in Finland in 2008 to that in 2012?
Your answer should be very brief. 1.04. What is the ratio of the % of total population in Portugal in 2008 to that in 2012?
Offer a very short reply. 1.11. What is the ratio of the % of total population in West Bank and Gaza in 2008 to that in 2012?
Keep it short and to the point. 0.94. What is the ratio of the % of total population of Latin America(all income levels) in 2009 to that in 2011?
Ensure brevity in your answer.  1.01. What is the ratio of the % of total population of Finland in 2009 to that in 2011?
Make the answer very short. 0.98. What is the ratio of the % of total population in Portugal in 2009 to that in 2011?
Ensure brevity in your answer.  0.99. What is the ratio of the % of total population in West Bank and Gaza in 2009 to that in 2011?
Offer a very short reply. 0.93. What is the ratio of the % of total population of Latin America(all income levels) in 2009 to that in 2012?
Your answer should be very brief. 1.02. What is the ratio of the % of total population of Finland in 2009 to that in 2012?
Your answer should be compact. 0.97. What is the ratio of the % of total population in Portugal in 2009 to that in 2012?
Keep it short and to the point. 1.02. What is the ratio of the % of total population of West Bank and Gaza in 2009 to that in 2012?
Make the answer very short. 0.88. What is the ratio of the % of total population of Finland in 2011 to that in 2012?
Make the answer very short. 0.99. What is the ratio of the % of total population of Portugal in 2011 to that in 2012?
Provide a succinct answer. 1.03. What is the ratio of the % of total population in West Bank and Gaza in 2011 to that in 2012?
Offer a terse response. 0.95. What is the difference between the highest and the second highest % of total population in Latin America(all income levels)?
Give a very brief answer. 0.9. What is the difference between the highest and the second highest % of total population in Portugal?
Offer a very short reply. 5.3. What is the difference between the highest and the lowest % of total population of Latin America(all income levels)?
Offer a terse response. 5.69. What is the difference between the highest and the lowest % of total population of Portugal?
Give a very brief answer. 13.2. What is the difference between the highest and the lowest % of total population in West Bank and Gaza?
Your answer should be very brief. 6.9. 